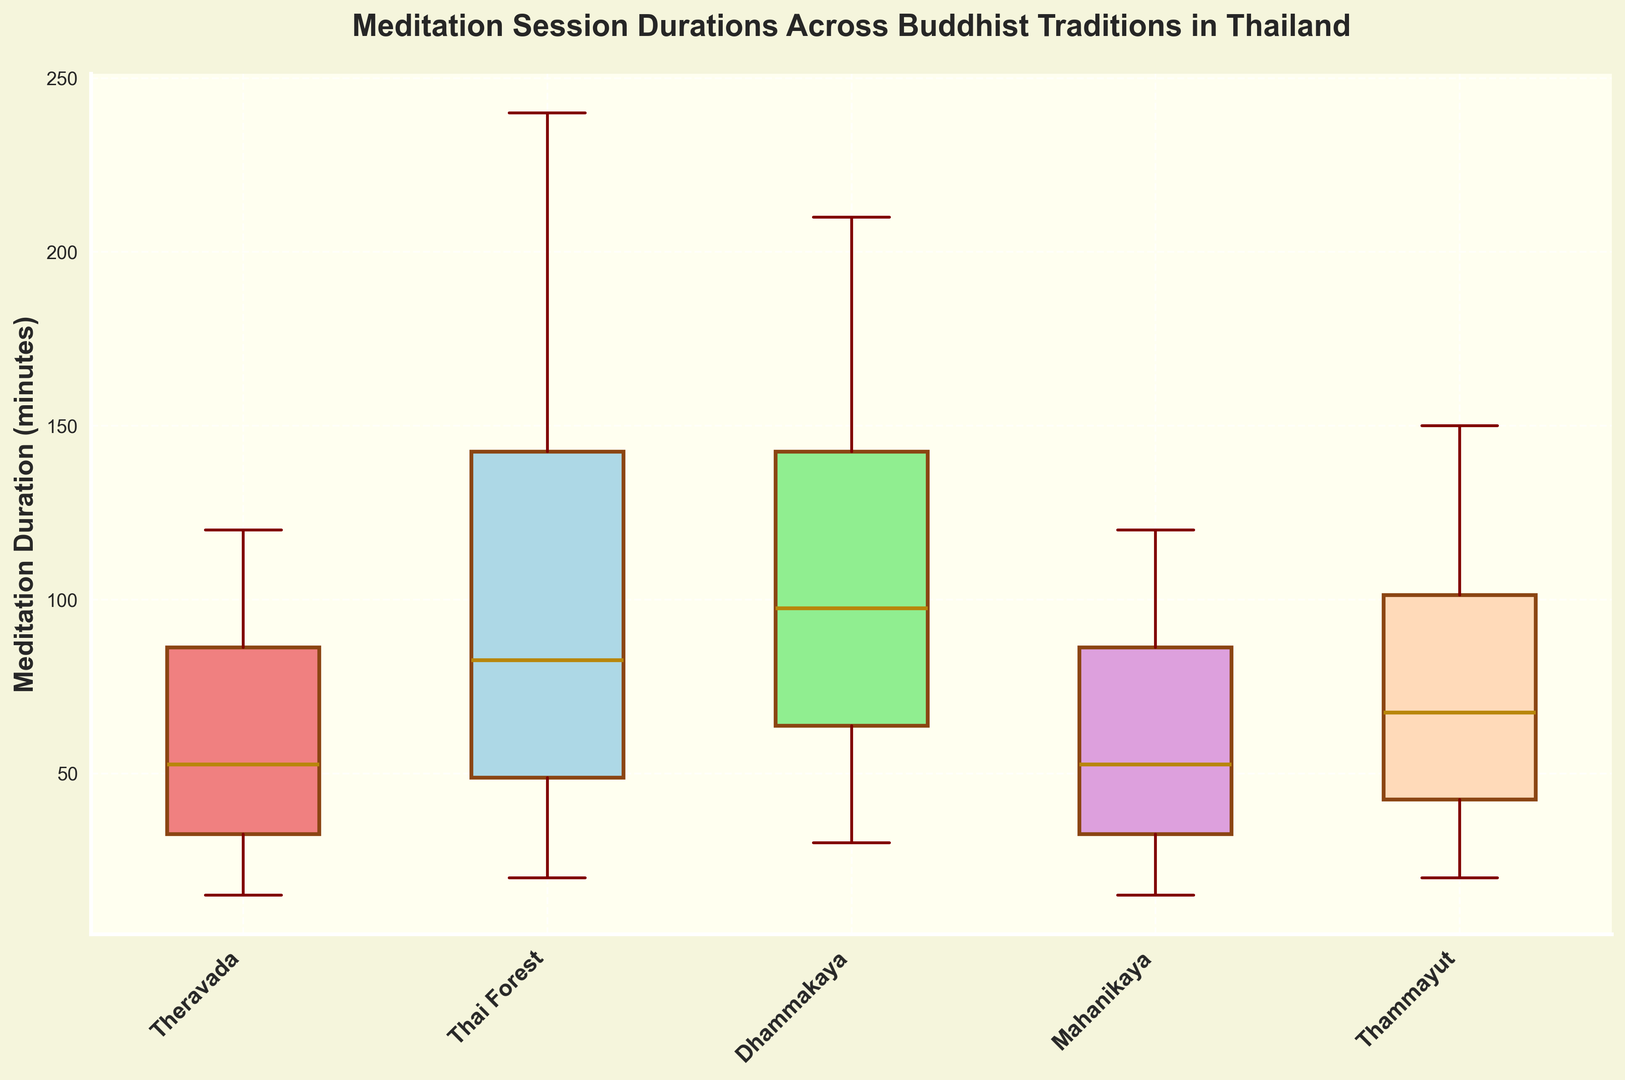What's the median duration for Theravada sessions? Find the box corresponding to Theravada. The line inside the box represents the median, which is the value that separates the higher half from the lower half of the data.
Answer: 47.5 Which tradition has the shortest minimum duration? Look at the lower whiskers of the boxes for each tradition to identify the one that has the shortest value.
Answer: Mahanikaya Between Dhammakaya and Thai Forest traditions, which one has the longer maximum duration? Compare the upper whiskers of the boxes for Dhammakaya and Thai Forest. The tradition with the higher upper whisker has the longer maximum duration.
Answer: Thai Forest What is the interquartile range (IQR) for Thammayut sessions? The IQR is the difference between the upper quartile (top of the box) and lower quartile (bottom of the box) for Thammayut. Measure the distance between these two points.
Answer: 90 minutes (120 - 30) Which two traditions have the most similar median session durations? Compare the line inside the boxes (medians) across traditions to find the two that are closest to each other.
Answer: Dhammakaya and Thai Forest Is the usual range of durations for Mahanikaya sessions wider or narrower than that for Thai Forest? Compare the lengths of the boxes (IQR) and the lengths of the whiskers to gauge the spread of the durations for both traditions.
Answer: Narrower What is the difference between the maximum duration in the Theravada tradition and the minimum duration in the Dhammakaya tradition? Identify the maximum value (upper whisker) in Theravada and the minimum value (lower whisker) in Dhammakaya, then calculate the difference between these two values.
Answer: 15 Which tradition has the most outliers in its data? Identify the tradition with the most "D" shaped markers outside the whiskers. These indicate outliers in the data.
Answer: Thai Forest What is the median duration for Thammayut compared to Mahanikaya? Compare the lines inside the boxes (medians) for Thammayut and Mahanikaya to determine which is higher or if they are equal.
Answer: Thammayut is higher Are there any traditions where the maximum or minimum durations are outliers? Check the boxplots to see if any whisker heights extend past the data range significantly, indicating outlier values.
Answer: No 